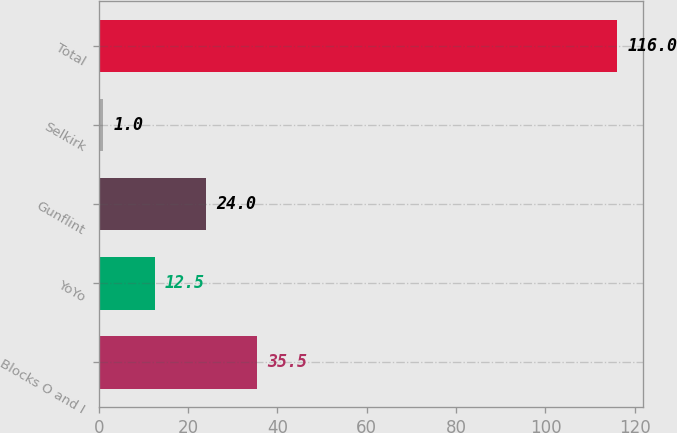<chart> <loc_0><loc_0><loc_500><loc_500><bar_chart><fcel>Blocks O and I<fcel>YoYo<fcel>Gunflint<fcel>Selkirk<fcel>Total<nl><fcel>35.5<fcel>12.5<fcel>24<fcel>1<fcel>116<nl></chart> 